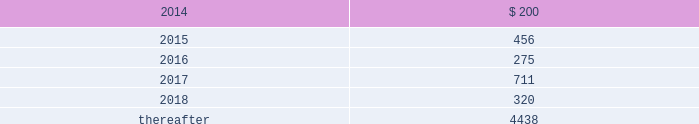The debentures are unsecured , subordinated and junior in right of payment and upon liquidation to all of the company 2019s existing and future senior indebtedness .
In addition , the debentures are effectively subordinated to all of the company 2019s subsidiaries 2019 existing and future indebtedness and other liabilities , including obligations to policyholders .
The debentures do not limit the company 2019s or the company 2019s subsidiaries 2019 ability to incur additional debt , including debt that ranks senior in right of payment and upon liquidation to the debentures .
The debentures rank equally in right of payment and upon liquidation with ( i ) any indebtedness the terms of which provide that such indebtedness ranks equally with the debentures , including guarantees of such indebtedness , ( ii ) the company 2019s existing 8.125% ( 8.125 % ) fixed- to-floating rate junior subordinated debentures due 2068 ( the 201c8.125% ( 201c8.125 % ) debentures 201d ) , ( iii ) the company 2019s income capital obligation notes due 2067 , issuable pursuant to the junior subordinated indenture , dated as of february 12 , 2007 , between the company and wilmington trust company ( the 201cicon securities 201d ) , ( iv ) our trade accounts payable , and ( v ) any of our indebtedness owed to a person who is our subsidiary or employee .
Long-term debt maturities long-term debt maturities ( at par values ) , as of december 31 , 2013 are summarized as follows: .
Shelf registrations on august 9 , 2013 , the company filed with the securities and exchange commission ( the 201csec 201d ) an automatic shelf registration statement ( registration no .
333-190506 ) for the potential offering and sale of debt and equity securities .
The registration statement allows for the following types of securities to be offered : debt securities , junior subordinated debt securities , preferred stock , common stock , depositary shares , warrants , stock purchase contracts , and stock purchase units .
In that the hartford is a well-known seasoned issuer , as defined in rule 405 under the securities act of 1933 , the registration statement went effective immediately upon filing and the hartford may offer and sell an unlimited amount of securities under the registration statement during the three-year life of the registration statement .
Contingent capital facility the company is party to a put option agreement that provides the hartford with the right to require the glen meadow abc trust , a delaware statutory trust , at any time and from time to time , to purchase the hartford 2019s junior subordinated notes in a maximum aggregate principal amount not to exceed $ 500 .
Under the put option agreement , the hartford will pay the glen meadow abc trust premiums on a periodic basis , calculated with respect to the aggregate principal amount of notes that the hartford had the right to put to the glen meadow abc trust for such period .
The hartford has agreed to reimburse the glen meadow abc trust for certain fees and ordinary expenses .
The company holds a variable interest in the glen meadow abc trust where the company is not the primary beneficiary .
As a result , the company did not consolidate the glen meadow abc trust .
As of december 31 , 2013 , the hartford has not exercised its right to require glen meadow abc trust to purchase the notes .
As a result , the notes remain a source of capital for the hfsg holding company .
Revolving credit facilities the company has a senior unsecured revolving credit facility ( the "credit facility" ) that provides for borrowing capacity up to $ 1.75 billion ( which is available in u.s .
Dollars , and in euro , sterling , canadian dollars and japanese yen ) through january 6 , 2016 .
As of december 31 , 2013 , there were no borrowings outstanding under the credit facility .
Of the total availability under the credit facility , up to $ 250 is available to support letters of credit issued on behalf of the company or subsidiaries of the company .
Under the credit facility , the company must maintain a minimum level of consolidated net worth of $ 14.9 billion .
The definition of consolidated net worth under the terms of the credit facility , excludes aoci and includes the company's outstanding junior subordinated debentures and , if any , perpetual preferred securities , net of discount .
In addition , the company 2019s maximum ratio of consolidated total debt to consolidated total capitalization is limited to 35% ( 35 % ) , and the ratio of consolidated total debt of subsidiaries to consolidated total capitalization is limited to 10% ( 10 % ) .
As of december 31 , 2013 , the company was in compliance with all financial covenants under the credit facility .
Table of contents the hartford financial services group , inc .
Notes to consolidated financial statements ( continued ) 13 .
Debt ( continued ) .
What is the total long-term debt reported in the balance sheet as of december 31 , 2013? 
Computations: (((((200 + 456) + 275) + 711) + 320) + 4438)
Answer: 6400.0. 